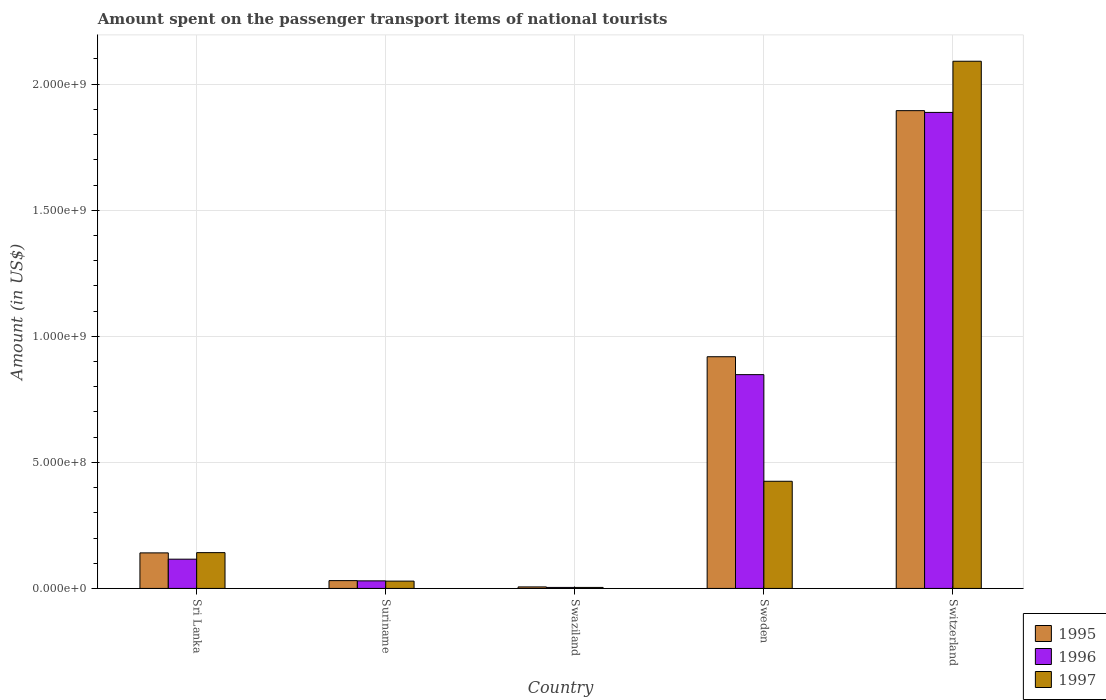How many groups of bars are there?
Give a very brief answer. 5. Are the number of bars per tick equal to the number of legend labels?
Offer a terse response. Yes. How many bars are there on the 2nd tick from the left?
Your answer should be very brief. 3. How many bars are there on the 1st tick from the right?
Your answer should be compact. 3. What is the label of the 4th group of bars from the left?
Make the answer very short. Sweden. In how many cases, is the number of bars for a given country not equal to the number of legend labels?
Ensure brevity in your answer.  0. What is the amount spent on the passenger transport items of national tourists in 1997 in Switzerland?
Provide a short and direct response. 2.09e+09. Across all countries, what is the maximum amount spent on the passenger transport items of national tourists in 1997?
Your answer should be very brief. 2.09e+09. In which country was the amount spent on the passenger transport items of national tourists in 1995 maximum?
Make the answer very short. Switzerland. In which country was the amount spent on the passenger transport items of national tourists in 1995 minimum?
Provide a short and direct response. Swaziland. What is the total amount spent on the passenger transport items of national tourists in 1995 in the graph?
Your response must be concise. 2.99e+09. What is the difference between the amount spent on the passenger transport items of national tourists in 1997 in Sri Lanka and that in Swaziland?
Give a very brief answer. 1.38e+08. What is the difference between the amount spent on the passenger transport items of national tourists in 1996 in Switzerland and the amount spent on the passenger transport items of national tourists in 1997 in Sri Lanka?
Make the answer very short. 1.75e+09. What is the average amount spent on the passenger transport items of national tourists in 1995 per country?
Your response must be concise. 5.98e+08. What is the difference between the amount spent on the passenger transport items of national tourists of/in 1996 and amount spent on the passenger transport items of national tourists of/in 1995 in Sweden?
Keep it short and to the point. -7.10e+07. In how many countries, is the amount spent on the passenger transport items of national tourists in 1996 greater than 1500000000 US$?
Your answer should be very brief. 1. What is the ratio of the amount spent on the passenger transport items of national tourists in 1996 in Sri Lanka to that in Swaziland?
Offer a very short reply. 29. Is the amount spent on the passenger transport items of national tourists in 1997 in Sri Lanka less than that in Suriname?
Provide a short and direct response. No. What is the difference between the highest and the second highest amount spent on the passenger transport items of national tourists in 1996?
Provide a short and direct response. 1.04e+09. What is the difference between the highest and the lowest amount spent on the passenger transport items of national tourists in 1995?
Ensure brevity in your answer.  1.89e+09. In how many countries, is the amount spent on the passenger transport items of national tourists in 1995 greater than the average amount spent on the passenger transport items of national tourists in 1995 taken over all countries?
Your answer should be very brief. 2. Is the sum of the amount spent on the passenger transport items of national tourists in 1996 in Suriname and Switzerland greater than the maximum amount spent on the passenger transport items of national tourists in 1995 across all countries?
Make the answer very short. Yes. What does the 1st bar from the left in Suriname represents?
Your answer should be very brief. 1995. What does the 2nd bar from the right in Switzerland represents?
Offer a very short reply. 1996. How many countries are there in the graph?
Keep it short and to the point. 5. Are the values on the major ticks of Y-axis written in scientific E-notation?
Ensure brevity in your answer.  Yes. Does the graph contain any zero values?
Your answer should be very brief. No. How are the legend labels stacked?
Give a very brief answer. Vertical. What is the title of the graph?
Your answer should be compact. Amount spent on the passenger transport items of national tourists. Does "2013" appear as one of the legend labels in the graph?
Offer a terse response. No. What is the label or title of the X-axis?
Provide a succinct answer. Country. What is the Amount (in US$) of 1995 in Sri Lanka?
Keep it short and to the point. 1.41e+08. What is the Amount (in US$) in 1996 in Sri Lanka?
Give a very brief answer. 1.16e+08. What is the Amount (in US$) of 1997 in Sri Lanka?
Provide a succinct answer. 1.42e+08. What is the Amount (in US$) of 1995 in Suriname?
Give a very brief answer. 3.10e+07. What is the Amount (in US$) in 1996 in Suriname?
Your answer should be compact. 3.00e+07. What is the Amount (in US$) of 1997 in Suriname?
Your answer should be compact. 2.90e+07. What is the Amount (in US$) of 1997 in Swaziland?
Your answer should be very brief. 4.00e+06. What is the Amount (in US$) of 1995 in Sweden?
Your response must be concise. 9.19e+08. What is the Amount (in US$) of 1996 in Sweden?
Keep it short and to the point. 8.48e+08. What is the Amount (in US$) in 1997 in Sweden?
Give a very brief answer. 4.25e+08. What is the Amount (in US$) of 1995 in Switzerland?
Make the answer very short. 1.90e+09. What is the Amount (in US$) of 1996 in Switzerland?
Offer a very short reply. 1.89e+09. What is the Amount (in US$) in 1997 in Switzerland?
Keep it short and to the point. 2.09e+09. Across all countries, what is the maximum Amount (in US$) in 1995?
Provide a succinct answer. 1.90e+09. Across all countries, what is the maximum Amount (in US$) in 1996?
Provide a short and direct response. 1.89e+09. Across all countries, what is the maximum Amount (in US$) in 1997?
Offer a very short reply. 2.09e+09. Across all countries, what is the minimum Amount (in US$) of 1995?
Your answer should be compact. 6.00e+06. What is the total Amount (in US$) of 1995 in the graph?
Keep it short and to the point. 2.99e+09. What is the total Amount (in US$) in 1996 in the graph?
Offer a very short reply. 2.89e+09. What is the total Amount (in US$) in 1997 in the graph?
Provide a succinct answer. 2.69e+09. What is the difference between the Amount (in US$) in 1995 in Sri Lanka and that in Suriname?
Your answer should be very brief. 1.10e+08. What is the difference between the Amount (in US$) of 1996 in Sri Lanka and that in Suriname?
Make the answer very short. 8.60e+07. What is the difference between the Amount (in US$) of 1997 in Sri Lanka and that in Suriname?
Your response must be concise. 1.13e+08. What is the difference between the Amount (in US$) of 1995 in Sri Lanka and that in Swaziland?
Make the answer very short. 1.35e+08. What is the difference between the Amount (in US$) in 1996 in Sri Lanka and that in Swaziland?
Ensure brevity in your answer.  1.12e+08. What is the difference between the Amount (in US$) in 1997 in Sri Lanka and that in Swaziland?
Offer a very short reply. 1.38e+08. What is the difference between the Amount (in US$) of 1995 in Sri Lanka and that in Sweden?
Give a very brief answer. -7.78e+08. What is the difference between the Amount (in US$) of 1996 in Sri Lanka and that in Sweden?
Your response must be concise. -7.32e+08. What is the difference between the Amount (in US$) of 1997 in Sri Lanka and that in Sweden?
Give a very brief answer. -2.83e+08. What is the difference between the Amount (in US$) of 1995 in Sri Lanka and that in Switzerland?
Your answer should be compact. -1.75e+09. What is the difference between the Amount (in US$) in 1996 in Sri Lanka and that in Switzerland?
Provide a succinct answer. -1.77e+09. What is the difference between the Amount (in US$) in 1997 in Sri Lanka and that in Switzerland?
Provide a succinct answer. -1.95e+09. What is the difference between the Amount (in US$) in 1995 in Suriname and that in Swaziland?
Provide a short and direct response. 2.50e+07. What is the difference between the Amount (in US$) of 1996 in Suriname and that in Swaziland?
Your answer should be very brief. 2.60e+07. What is the difference between the Amount (in US$) in 1997 in Suriname and that in Swaziland?
Give a very brief answer. 2.50e+07. What is the difference between the Amount (in US$) of 1995 in Suriname and that in Sweden?
Ensure brevity in your answer.  -8.88e+08. What is the difference between the Amount (in US$) in 1996 in Suriname and that in Sweden?
Provide a succinct answer. -8.18e+08. What is the difference between the Amount (in US$) in 1997 in Suriname and that in Sweden?
Your response must be concise. -3.96e+08. What is the difference between the Amount (in US$) in 1995 in Suriname and that in Switzerland?
Your answer should be very brief. -1.86e+09. What is the difference between the Amount (in US$) of 1996 in Suriname and that in Switzerland?
Give a very brief answer. -1.86e+09. What is the difference between the Amount (in US$) in 1997 in Suriname and that in Switzerland?
Give a very brief answer. -2.06e+09. What is the difference between the Amount (in US$) in 1995 in Swaziland and that in Sweden?
Make the answer very short. -9.13e+08. What is the difference between the Amount (in US$) in 1996 in Swaziland and that in Sweden?
Ensure brevity in your answer.  -8.44e+08. What is the difference between the Amount (in US$) of 1997 in Swaziland and that in Sweden?
Provide a succinct answer. -4.21e+08. What is the difference between the Amount (in US$) of 1995 in Swaziland and that in Switzerland?
Provide a short and direct response. -1.89e+09. What is the difference between the Amount (in US$) of 1996 in Swaziland and that in Switzerland?
Your answer should be very brief. -1.88e+09. What is the difference between the Amount (in US$) of 1997 in Swaziland and that in Switzerland?
Ensure brevity in your answer.  -2.09e+09. What is the difference between the Amount (in US$) of 1995 in Sweden and that in Switzerland?
Give a very brief answer. -9.76e+08. What is the difference between the Amount (in US$) of 1996 in Sweden and that in Switzerland?
Provide a short and direct response. -1.04e+09. What is the difference between the Amount (in US$) of 1997 in Sweden and that in Switzerland?
Your answer should be compact. -1.67e+09. What is the difference between the Amount (in US$) of 1995 in Sri Lanka and the Amount (in US$) of 1996 in Suriname?
Ensure brevity in your answer.  1.11e+08. What is the difference between the Amount (in US$) in 1995 in Sri Lanka and the Amount (in US$) in 1997 in Suriname?
Provide a short and direct response. 1.12e+08. What is the difference between the Amount (in US$) of 1996 in Sri Lanka and the Amount (in US$) of 1997 in Suriname?
Your answer should be very brief. 8.70e+07. What is the difference between the Amount (in US$) of 1995 in Sri Lanka and the Amount (in US$) of 1996 in Swaziland?
Ensure brevity in your answer.  1.37e+08. What is the difference between the Amount (in US$) of 1995 in Sri Lanka and the Amount (in US$) of 1997 in Swaziland?
Give a very brief answer. 1.37e+08. What is the difference between the Amount (in US$) in 1996 in Sri Lanka and the Amount (in US$) in 1997 in Swaziland?
Your answer should be compact. 1.12e+08. What is the difference between the Amount (in US$) of 1995 in Sri Lanka and the Amount (in US$) of 1996 in Sweden?
Your response must be concise. -7.07e+08. What is the difference between the Amount (in US$) in 1995 in Sri Lanka and the Amount (in US$) in 1997 in Sweden?
Your answer should be very brief. -2.84e+08. What is the difference between the Amount (in US$) of 1996 in Sri Lanka and the Amount (in US$) of 1997 in Sweden?
Keep it short and to the point. -3.09e+08. What is the difference between the Amount (in US$) of 1995 in Sri Lanka and the Amount (in US$) of 1996 in Switzerland?
Offer a very short reply. -1.75e+09. What is the difference between the Amount (in US$) of 1995 in Sri Lanka and the Amount (in US$) of 1997 in Switzerland?
Ensure brevity in your answer.  -1.95e+09. What is the difference between the Amount (in US$) in 1996 in Sri Lanka and the Amount (in US$) in 1997 in Switzerland?
Give a very brief answer. -1.98e+09. What is the difference between the Amount (in US$) in 1995 in Suriname and the Amount (in US$) in 1996 in Swaziland?
Your answer should be compact. 2.70e+07. What is the difference between the Amount (in US$) of 1995 in Suriname and the Amount (in US$) of 1997 in Swaziland?
Ensure brevity in your answer.  2.70e+07. What is the difference between the Amount (in US$) in 1996 in Suriname and the Amount (in US$) in 1997 in Swaziland?
Your answer should be very brief. 2.60e+07. What is the difference between the Amount (in US$) of 1995 in Suriname and the Amount (in US$) of 1996 in Sweden?
Provide a succinct answer. -8.17e+08. What is the difference between the Amount (in US$) of 1995 in Suriname and the Amount (in US$) of 1997 in Sweden?
Your answer should be very brief. -3.94e+08. What is the difference between the Amount (in US$) of 1996 in Suriname and the Amount (in US$) of 1997 in Sweden?
Keep it short and to the point. -3.95e+08. What is the difference between the Amount (in US$) in 1995 in Suriname and the Amount (in US$) in 1996 in Switzerland?
Keep it short and to the point. -1.86e+09. What is the difference between the Amount (in US$) in 1995 in Suriname and the Amount (in US$) in 1997 in Switzerland?
Your response must be concise. -2.06e+09. What is the difference between the Amount (in US$) in 1996 in Suriname and the Amount (in US$) in 1997 in Switzerland?
Make the answer very short. -2.06e+09. What is the difference between the Amount (in US$) in 1995 in Swaziland and the Amount (in US$) in 1996 in Sweden?
Keep it short and to the point. -8.42e+08. What is the difference between the Amount (in US$) of 1995 in Swaziland and the Amount (in US$) of 1997 in Sweden?
Give a very brief answer. -4.19e+08. What is the difference between the Amount (in US$) in 1996 in Swaziland and the Amount (in US$) in 1997 in Sweden?
Make the answer very short. -4.21e+08. What is the difference between the Amount (in US$) of 1995 in Swaziland and the Amount (in US$) of 1996 in Switzerland?
Ensure brevity in your answer.  -1.88e+09. What is the difference between the Amount (in US$) of 1995 in Swaziland and the Amount (in US$) of 1997 in Switzerland?
Make the answer very short. -2.08e+09. What is the difference between the Amount (in US$) in 1996 in Swaziland and the Amount (in US$) in 1997 in Switzerland?
Ensure brevity in your answer.  -2.09e+09. What is the difference between the Amount (in US$) in 1995 in Sweden and the Amount (in US$) in 1996 in Switzerland?
Your answer should be very brief. -9.69e+08. What is the difference between the Amount (in US$) in 1995 in Sweden and the Amount (in US$) in 1997 in Switzerland?
Ensure brevity in your answer.  -1.17e+09. What is the difference between the Amount (in US$) of 1996 in Sweden and the Amount (in US$) of 1997 in Switzerland?
Offer a very short reply. -1.24e+09. What is the average Amount (in US$) in 1995 per country?
Provide a succinct answer. 5.98e+08. What is the average Amount (in US$) in 1996 per country?
Your answer should be very brief. 5.77e+08. What is the average Amount (in US$) of 1997 per country?
Offer a terse response. 5.38e+08. What is the difference between the Amount (in US$) in 1995 and Amount (in US$) in 1996 in Sri Lanka?
Your answer should be very brief. 2.50e+07. What is the difference between the Amount (in US$) of 1996 and Amount (in US$) of 1997 in Sri Lanka?
Give a very brief answer. -2.60e+07. What is the difference between the Amount (in US$) in 1995 and Amount (in US$) in 1996 in Suriname?
Give a very brief answer. 1.00e+06. What is the difference between the Amount (in US$) in 1996 and Amount (in US$) in 1997 in Suriname?
Provide a short and direct response. 1.00e+06. What is the difference between the Amount (in US$) of 1995 and Amount (in US$) of 1996 in Swaziland?
Offer a very short reply. 2.00e+06. What is the difference between the Amount (in US$) of 1995 and Amount (in US$) of 1997 in Swaziland?
Your response must be concise. 2.00e+06. What is the difference between the Amount (in US$) in 1995 and Amount (in US$) in 1996 in Sweden?
Your answer should be compact. 7.10e+07. What is the difference between the Amount (in US$) in 1995 and Amount (in US$) in 1997 in Sweden?
Offer a very short reply. 4.94e+08. What is the difference between the Amount (in US$) of 1996 and Amount (in US$) of 1997 in Sweden?
Provide a short and direct response. 4.23e+08. What is the difference between the Amount (in US$) in 1995 and Amount (in US$) in 1996 in Switzerland?
Your answer should be compact. 7.00e+06. What is the difference between the Amount (in US$) of 1995 and Amount (in US$) of 1997 in Switzerland?
Give a very brief answer. -1.96e+08. What is the difference between the Amount (in US$) of 1996 and Amount (in US$) of 1997 in Switzerland?
Provide a short and direct response. -2.03e+08. What is the ratio of the Amount (in US$) of 1995 in Sri Lanka to that in Suriname?
Give a very brief answer. 4.55. What is the ratio of the Amount (in US$) of 1996 in Sri Lanka to that in Suriname?
Offer a very short reply. 3.87. What is the ratio of the Amount (in US$) in 1997 in Sri Lanka to that in Suriname?
Keep it short and to the point. 4.9. What is the ratio of the Amount (in US$) in 1995 in Sri Lanka to that in Swaziland?
Keep it short and to the point. 23.5. What is the ratio of the Amount (in US$) in 1997 in Sri Lanka to that in Swaziland?
Provide a succinct answer. 35.5. What is the ratio of the Amount (in US$) in 1995 in Sri Lanka to that in Sweden?
Provide a succinct answer. 0.15. What is the ratio of the Amount (in US$) of 1996 in Sri Lanka to that in Sweden?
Ensure brevity in your answer.  0.14. What is the ratio of the Amount (in US$) of 1997 in Sri Lanka to that in Sweden?
Provide a short and direct response. 0.33. What is the ratio of the Amount (in US$) of 1995 in Sri Lanka to that in Switzerland?
Make the answer very short. 0.07. What is the ratio of the Amount (in US$) of 1996 in Sri Lanka to that in Switzerland?
Give a very brief answer. 0.06. What is the ratio of the Amount (in US$) of 1997 in Sri Lanka to that in Switzerland?
Ensure brevity in your answer.  0.07. What is the ratio of the Amount (in US$) in 1995 in Suriname to that in Swaziland?
Your answer should be compact. 5.17. What is the ratio of the Amount (in US$) of 1997 in Suriname to that in Swaziland?
Provide a short and direct response. 7.25. What is the ratio of the Amount (in US$) in 1995 in Suriname to that in Sweden?
Your answer should be very brief. 0.03. What is the ratio of the Amount (in US$) in 1996 in Suriname to that in Sweden?
Your response must be concise. 0.04. What is the ratio of the Amount (in US$) in 1997 in Suriname to that in Sweden?
Make the answer very short. 0.07. What is the ratio of the Amount (in US$) of 1995 in Suriname to that in Switzerland?
Provide a succinct answer. 0.02. What is the ratio of the Amount (in US$) in 1996 in Suriname to that in Switzerland?
Provide a short and direct response. 0.02. What is the ratio of the Amount (in US$) of 1997 in Suriname to that in Switzerland?
Your answer should be compact. 0.01. What is the ratio of the Amount (in US$) in 1995 in Swaziland to that in Sweden?
Offer a terse response. 0.01. What is the ratio of the Amount (in US$) of 1996 in Swaziland to that in Sweden?
Ensure brevity in your answer.  0. What is the ratio of the Amount (in US$) of 1997 in Swaziland to that in Sweden?
Give a very brief answer. 0.01. What is the ratio of the Amount (in US$) in 1995 in Swaziland to that in Switzerland?
Keep it short and to the point. 0. What is the ratio of the Amount (in US$) in 1996 in Swaziland to that in Switzerland?
Keep it short and to the point. 0. What is the ratio of the Amount (in US$) in 1997 in Swaziland to that in Switzerland?
Offer a terse response. 0. What is the ratio of the Amount (in US$) of 1995 in Sweden to that in Switzerland?
Your answer should be very brief. 0.48. What is the ratio of the Amount (in US$) in 1996 in Sweden to that in Switzerland?
Your answer should be compact. 0.45. What is the ratio of the Amount (in US$) in 1997 in Sweden to that in Switzerland?
Offer a terse response. 0.2. What is the difference between the highest and the second highest Amount (in US$) in 1995?
Offer a very short reply. 9.76e+08. What is the difference between the highest and the second highest Amount (in US$) of 1996?
Offer a terse response. 1.04e+09. What is the difference between the highest and the second highest Amount (in US$) in 1997?
Your response must be concise. 1.67e+09. What is the difference between the highest and the lowest Amount (in US$) of 1995?
Ensure brevity in your answer.  1.89e+09. What is the difference between the highest and the lowest Amount (in US$) in 1996?
Offer a terse response. 1.88e+09. What is the difference between the highest and the lowest Amount (in US$) of 1997?
Your answer should be very brief. 2.09e+09. 